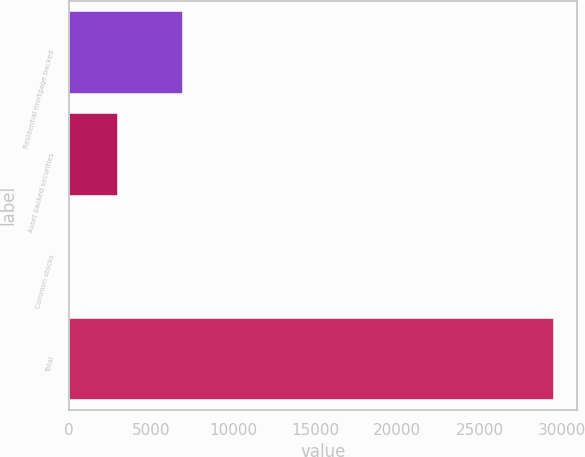<chart> <loc_0><loc_0><loc_500><loc_500><bar_chart><fcel>Residential mortgage backed<fcel>Asset backed securities<fcel>Common stocks<fcel>Total<nl><fcel>6899<fcel>2956.2<fcel>10<fcel>29472<nl></chart> 